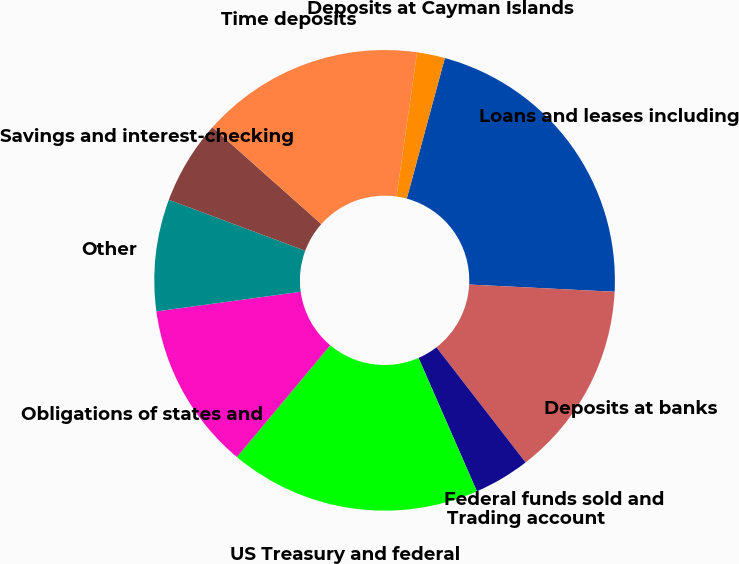Convert chart to OTSL. <chart><loc_0><loc_0><loc_500><loc_500><pie_chart><fcel>Loans and leases including<fcel>Deposits at banks<fcel>Federal funds sold and<fcel>Trading account<fcel>US Treasury and federal<fcel>Obligations of states and<fcel>Other<fcel>Savings and interest-checking<fcel>Time deposits<fcel>Deposits at Cayman Islands<nl><fcel>21.57%<fcel>13.72%<fcel>0.0%<fcel>3.92%<fcel>17.64%<fcel>11.76%<fcel>7.84%<fcel>5.88%<fcel>15.68%<fcel>1.96%<nl></chart> 